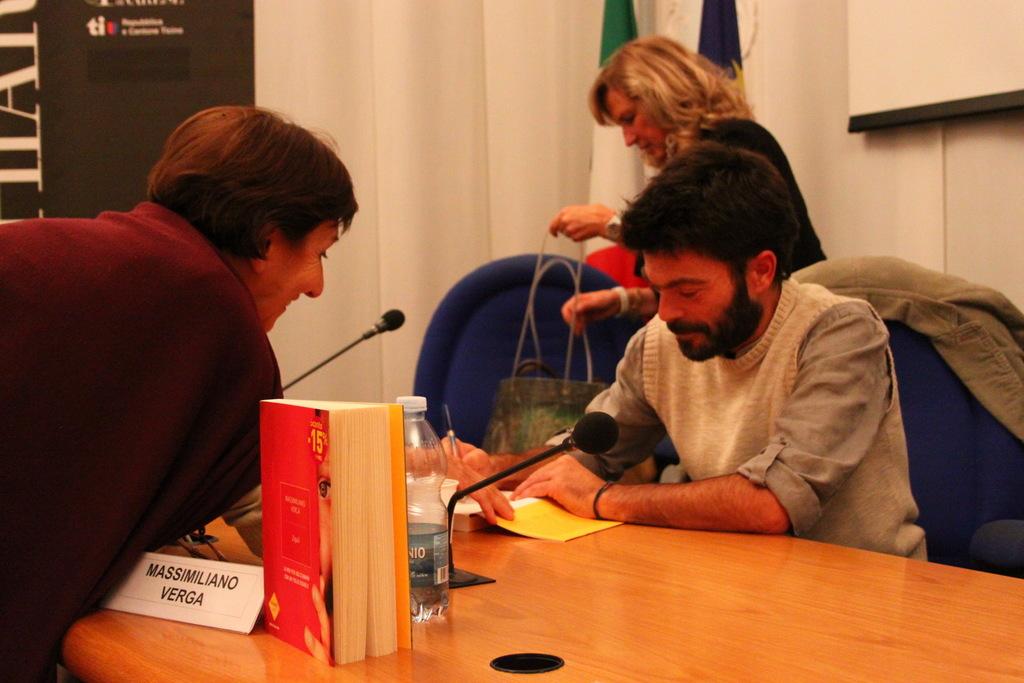What name is on the nametag on the desk?
Your response must be concise. Massimiliano verga. 